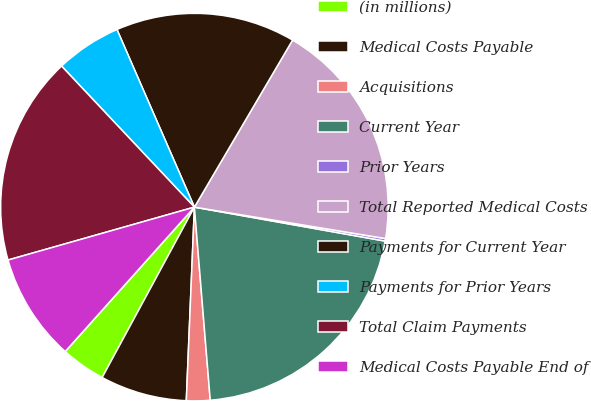<chart> <loc_0><loc_0><loc_500><loc_500><pie_chart><fcel>(in millions)<fcel>Medical Costs Payable<fcel>Acquisitions<fcel>Current Year<fcel>Prior Years<fcel>Total Reported Medical Costs<fcel>Payments for Current Year<fcel>Payments for Prior Years<fcel>Total Claim Payments<fcel>Medical Costs Payable End of<nl><fcel>3.72%<fcel>7.23%<fcel>1.97%<fcel>20.89%<fcel>0.21%<fcel>19.14%<fcel>15.0%<fcel>5.48%<fcel>17.38%<fcel>8.98%<nl></chart> 